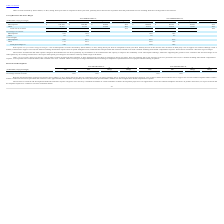From Ringcentral's financial document, What are the respective drivers of the company's increased cost of revenue in 2019? The document contains multiple relevant values: third-party costs to support our solution offerings, infrastructure support costs, headcount and personnel and contractor related costs. From the document: "tion expense from acquired intangible assets, and headcount and personnel and contractor related costs of $9.6 million including share-based compensat..." Also, What caused the increased in headcount and other expense? investments in our infrastructure and capacity to improve the availability of our subscription offerings, while also supporting the growth in new customers and increased usage of our subscriptions by our existing customer base. The document states: "tegories described herein was driven primarily by investments in our infrastructure and capacity to improve the availability of our subscription offer..." Also, What are the factors influencing the cost of revenues and gross margins in 2019? The document contains multiple relevant values: increase in services personnel costs, cost of product sales, overhead costs. From the document: "ense, cost of product sales of $10.6 million, and overhead costs of $1.3 million. Other revenues gross margin fluctuates based on timing of completion..." Also, can you calculate: What is the average cost of subscription between 2017 to 2019? To answer this question, I need to perform calculations using the financial data. The calculation is: (89,193 + 109,454 + 160,320)/3 , which equals 119655.67 (in thousands). This is based on the information: "Subscriptions $ 160,320 $ 109,454 $ 50,866 46% $ 109,454 $ 89,193 $ 20,261 23% Subscriptions $ 160,320 $ 109,454 $ 50,866 46% $ 109,454 $ 89,193 $ 20,261 23% ions $ 160,320 $ 109,454 $ 50,866 46% $ 10..." The key data points involved are: 109,454, 160,320, 89,193. Also, can you calculate: What is the value of the subscription costs as a percentage of the total cost of revenue in 2019? Based on the calculation: 160,320/231,043 , the result is 69.39 (percentage). This is based on the information: "Total cost of revenues $ 231,043 $ 157,129 $ 73,914 47% $ 157,129 $ 121,271 $ 35,858 30% Subscriptions $ 160,320 $ 109,454 $ 50,866 46% $ 109,454 $ 89,193 $ 20,261 23%..." The key data points involved are: 160,320, 231,043. Also, can you calculate: What is the average total cost of revenue between 2017 to 2019? To answer this question, I need to perform calculations using the financial data. The calculation is: (121,271 + 157,129 + 231,043)/3 , which equals 169814.33 (in thousands). This is based on the information: "Total cost of revenues $ 231,043 $ 157,129 $ 73,914 47% $ 157,129 $ 121,271 $ 35,858 30% Total cost of revenues $ 231,043 $ 157,129 $ 73,914 47% $ 157,129 $ 121,271 $ 35,858 30% nues $ 231,043 $ 157,1..." The key data points involved are: 121,271, 157,129, 231,043. 